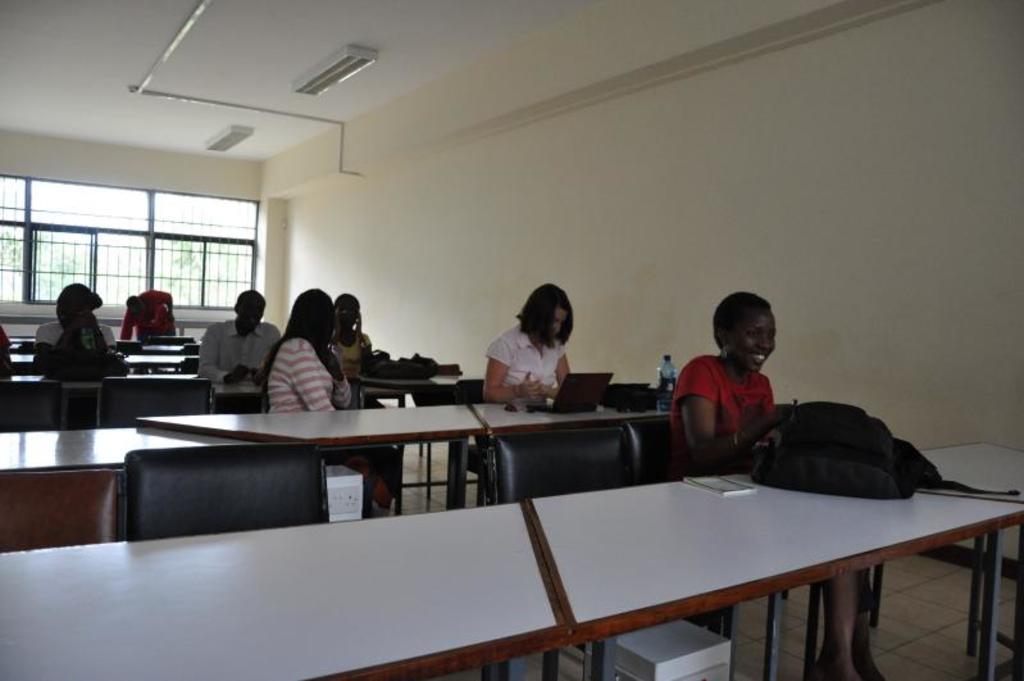Describe this image in one or two sentences. There are group of people sitting in a chair and there is a table in front of them and there is a window in the background. 